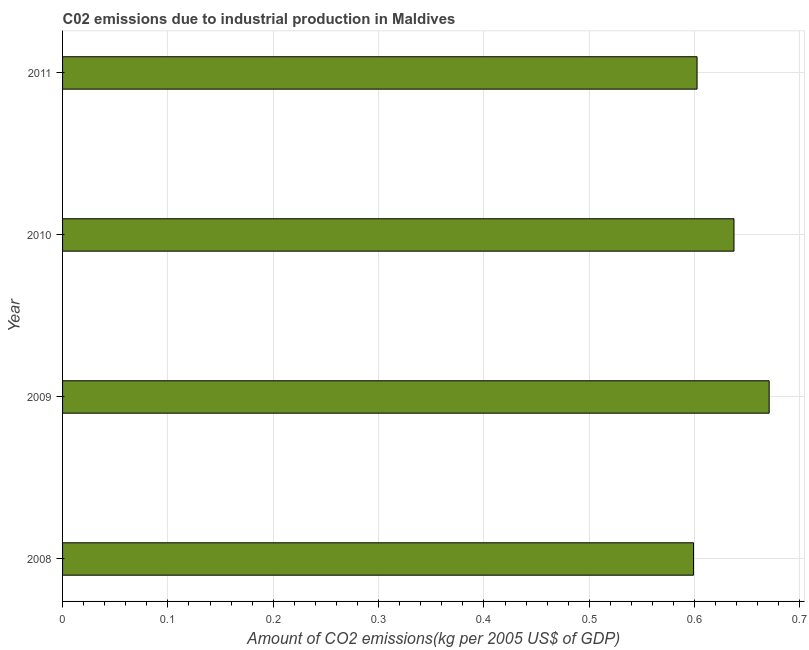Does the graph contain any zero values?
Give a very brief answer. No. Does the graph contain grids?
Offer a very short reply. Yes. What is the title of the graph?
Offer a very short reply. C02 emissions due to industrial production in Maldives. What is the label or title of the X-axis?
Your answer should be compact. Amount of CO2 emissions(kg per 2005 US$ of GDP). What is the amount of co2 emissions in 2011?
Your response must be concise. 0.6. Across all years, what is the maximum amount of co2 emissions?
Make the answer very short. 0.67. Across all years, what is the minimum amount of co2 emissions?
Keep it short and to the point. 0.6. In which year was the amount of co2 emissions maximum?
Make the answer very short. 2009. In which year was the amount of co2 emissions minimum?
Offer a terse response. 2008. What is the sum of the amount of co2 emissions?
Offer a very short reply. 2.51. What is the difference between the amount of co2 emissions in 2008 and 2011?
Give a very brief answer. -0. What is the average amount of co2 emissions per year?
Provide a short and direct response. 0.63. What is the median amount of co2 emissions?
Offer a very short reply. 0.62. In how many years, is the amount of co2 emissions greater than 0.12 kg per 2005 US$ of GDP?
Give a very brief answer. 4. Do a majority of the years between 2009 and 2010 (inclusive) have amount of co2 emissions greater than 0.44 kg per 2005 US$ of GDP?
Give a very brief answer. Yes. What is the difference between the highest and the second highest amount of co2 emissions?
Keep it short and to the point. 0.03. What is the difference between the highest and the lowest amount of co2 emissions?
Make the answer very short. 0.07. Are all the bars in the graph horizontal?
Ensure brevity in your answer.  Yes. Are the values on the major ticks of X-axis written in scientific E-notation?
Ensure brevity in your answer.  No. What is the Amount of CO2 emissions(kg per 2005 US$ of GDP) of 2008?
Your response must be concise. 0.6. What is the Amount of CO2 emissions(kg per 2005 US$ of GDP) in 2009?
Make the answer very short. 0.67. What is the Amount of CO2 emissions(kg per 2005 US$ of GDP) in 2010?
Provide a short and direct response. 0.64. What is the Amount of CO2 emissions(kg per 2005 US$ of GDP) in 2011?
Make the answer very short. 0.6. What is the difference between the Amount of CO2 emissions(kg per 2005 US$ of GDP) in 2008 and 2009?
Offer a terse response. -0.07. What is the difference between the Amount of CO2 emissions(kg per 2005 US$ of GDP) in 2008 and 2010?
Provide a succinct answer. -0.04. What is the difference between the Amount of CO2 emissions(kg per 2005 US$ of GDP) in 2008 and 2011?
Your answer should be very brief. -0. What is the difference between the Amount of CO2 emissions(kg per 2005 US$ of GDP) in 2009 and 2010?
Ensure brevity in your answer.  0.03. What is the difference between the Amount of CO2 emissions(kg per 2005 US$ of GDP) in 2009 and 2011?
Your answer should be very brief. 0.07. What is the difference between the Amount of CO2 emissions(kg per 2005 US$ of GDP) in 2010 and 2011?
Keep it short and to the point. 0.04. What is the ratio of the Amount of CO2 emissions(kg per 2005 US$ of GDP) in 2008 to that in 2009?
Offer a terse response. 0.89. What is the ratio of the Amount of CO2 emissions(kg per 2005 US$ of GDP) in 2008 to that in 2010?
Offer a terse response. 0.94. What is the ratio of the Amount of CO2 emissions(kg per 2005 US$ of GDP) in 2009 to that in 2010?
Make the answer very short. 1.05. What is the ratio of the Amount of CO2 emissions(kg per 2005 US$ of GDP) in 2009 to that in 2011?
Provide a succinct answer. 1.11. What is the ratio of the Amount of CO2 emissions(kg per 2005 US$ of GDP) in 2010 to that in 2011?
Provide a short and direct response. 1.06. 